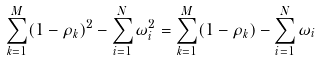Convert formula to latex. <formula><loc_0><loc_0><loc_500><loc_500>\sum _ { k = 1 } ^ { M } ( 1 - \rho _ { k } ) ^ { 2 } - \sum _ { i = 1 } ^ { N } \omega _ { i } ^ { 2 } = \sum _ { k = 1 } ^ { M } ( 1 - \rho _ { k } ) - \sum _ { i = 1 } ^ { N } \omega _ { i }</formula> 